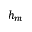<formula> <loc_0><loc_0><loc_500><loc_500>h _ { m }</formula> 